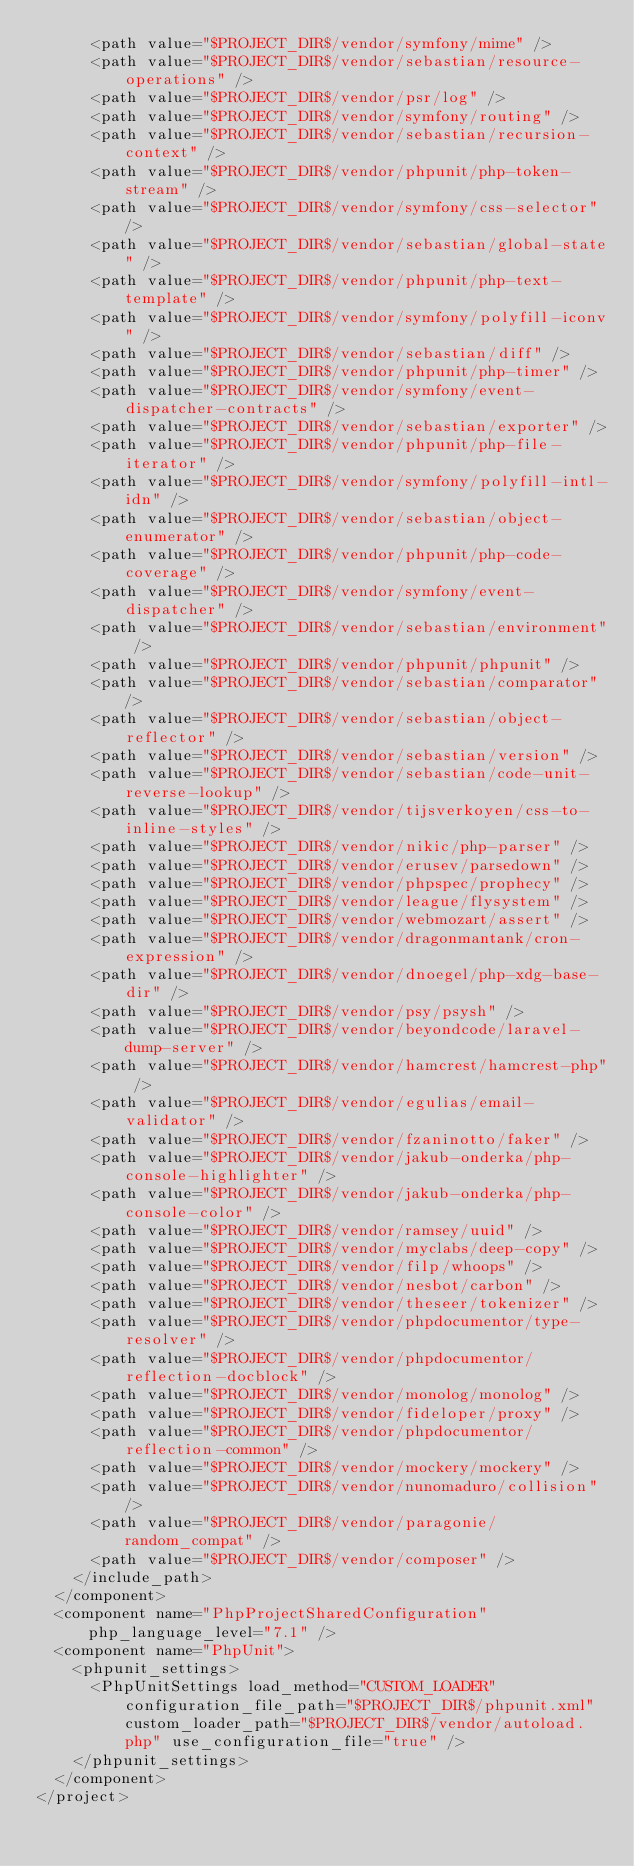Convert code to text. <code><loc_0><loc_0><loc_500><loc_500><_XML_>      <path value="$PROJECT_DIR$/vendor/symfony/mime" />
      <path value="$PROJECT_DIR$/vendor/sebastian/resource-operations" />
      <path value="$PROJECT_DIR$/vendor/psr/log" />
      <path value="$PROJECT_DIR$/vendor/symfony/routing" />
      <path value="$PROJECT_DIR$/vendor/sebastian/recursion-context" />
      <path value="$PROJECT_DIR$/vendor/phpunit/php-token-stream" />
      <path value="$PROJECT_DIR$/vendor/symfony/css-selector" />
      <path value="$PROJECT_DIR$/vendor/sebastian/global-state" />
      <path value="$PROJECT_DIR$/vendor/phpunit/php-text-template" />
      <path value="$PROJECT_DIR$/vendor/symfony/polyfill-iconv" />
      <path value="$PROJECT_DIR$/vendor/sebastian/diff" />
      <path value="$PROJECT_DIR$/vendor/phpunit/php-timer" />
      <path value="$PROJECT_DIR$/vendor/symfony/event-dispatcher-contracts" />
      <path value="$PROJECT_DIR$/vendor/sebastian/exporter" />
      <path value="$PROJECT_DIR$/vendor/phpunit/php-file-iterator" />
      <path value="$PROJECT_DIR$/vendor/symfony/polyfill-intl-idn" />
      <path value="$PROJECT_DIR$/vendor/sebastian/object-enumerator" />
      <path value="$PROJECT_DIR$/vendor/phpunit/php-code-coverage" />
      <path value="$PROJECT_DIR$/vendor/symfony/event-dispatcher" />
      <path value="$PROJECT_DIR$/vendor/sebastian/environment" />
      <path value="$PROJECT_DIR$/vendor/phpunit/phpunit" />
      <path value="$PROJECT_DIR$/vendor/sebastian/comparator" />
      <path value="$PROJECT_DIR$/vendor/sebastian/object-reflector" />
      <path value="$PROJECT_DIR$/vendor/sebastian/version" />
      <path value="$PROJECT_DIR$/vendor/sebastian/code-unit-reverse-lookup" />
      <path value="$PROJECT_DIR$/vendor/tijsverkoyen/css-to-inline-styles" />
      <path value="$PROJECT_DIR$/vendor/nikic/php-parser" />
      <path value="$PROJECT_DIR$/vendor/erusev/parsedown" />
      <path value="$PROJECT_DIR$/vendor/phpspec/prophecy" />
      <path value="$PROJECT_DIR$/vendor/league/flysystem" />
      <path value="$PROJECT_DIR$/vendor/webmozart/assert" />
      <path value="$PROJECT_DIR$/vendor/dragonmantank/cron-expression" />
      <path value="$PROJECT_DIR$/vendor/dnoegel/php-xdg-base-dir" />
      <path value="$PROJECT_DIR$/vendor/psy/psysh" />
      <path value="$PROJECT_DIR$/vendor/beyondcode/laravel-dump-server" />
      <path value="$PROJECT_DIR$/vendor/hamcrest/hamcrest-php" />
      <path value="$PROJECT_DIR$/vendor/egulias/email-validator" />
      <path value="$PROJECT_DIR$/vendor/fzaninotto/faker" />
      <path value="$PROJECT_DIR$/vendor/jakub-onderka/php-console-highlighter" />
      <path value="$PROJECT_DIR$/vendor/jakub-onderka/php-console-color" />
      <path value="$PROJECT_DIR$/vendor/ramsey/uuid" />
      <path value="$PROJECT_DIR$/vendor/myclabs/deep-copy" />
      <path value="$PROJECT_DIR$/vendor/filp/whoops" />
      <path value="$PROJECT_DIR$/vendor/nesbot/carbon" />
      <path value="$PROJECT_DIR$/vendor/theseer/tokenizer" />
      <path value="$PROJECT_DIR$/vendor/phpdocumentor/type-resolver" />
      <path value="$PROJECT_DIR$/vendor/phpdocumentor/reflection-docblock" />
      <path value="$PROJECT_DIR$/vendor/monolog/monolog" />
      <path value="$PROJECT_DIR$/vendor/fideloper/proxy" />
      <path value="$PROJECT_DIR$/vendor/phpdocumentor/reflection-common" />
      <path value="$PROJECT_DIR$/vendor/mockery/mockery" />
      <path value="$PROJECT_DIR$/vendor/nunomaduro/collision" />
      <path value="$PROJECT_DIR$/vendor/paragonie/random_compat" />
      <path value="$PROJECT_DIR$/vendor/composer" />
    </include_path>
  </component>
  <component name="PhpProjectSharedConfiguration" php_language_level="7.1" />
  <component name="PhpUnit">
    <phpunit_settings>
      <PhpUnitSettings load_method="CUSTOM_LOADER" configuration_file_path="$PROJECT_DIR$/phpunit.xml" custom_loader_path="$PROJECT_DIR$/vendor/autoload.php" use_configuration_file="true" />
    </phpunit_settings>
  </component>
</project></code> 